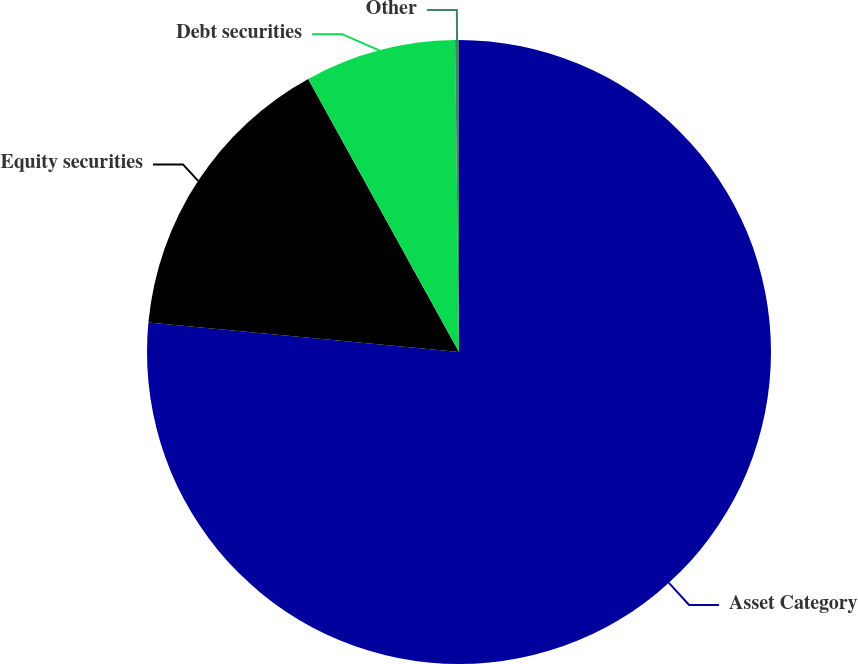<chart> <loc_0><loc_0><loc_500><loc_500><pie_chart><fcel>Asset Category<fcel>Equity securities<fcel>Debt securities<fcel>Other<nl><fcel>76.51%<fcel>15.46%<fcel>7.83%<fcel>0.2%<nl></chart> 